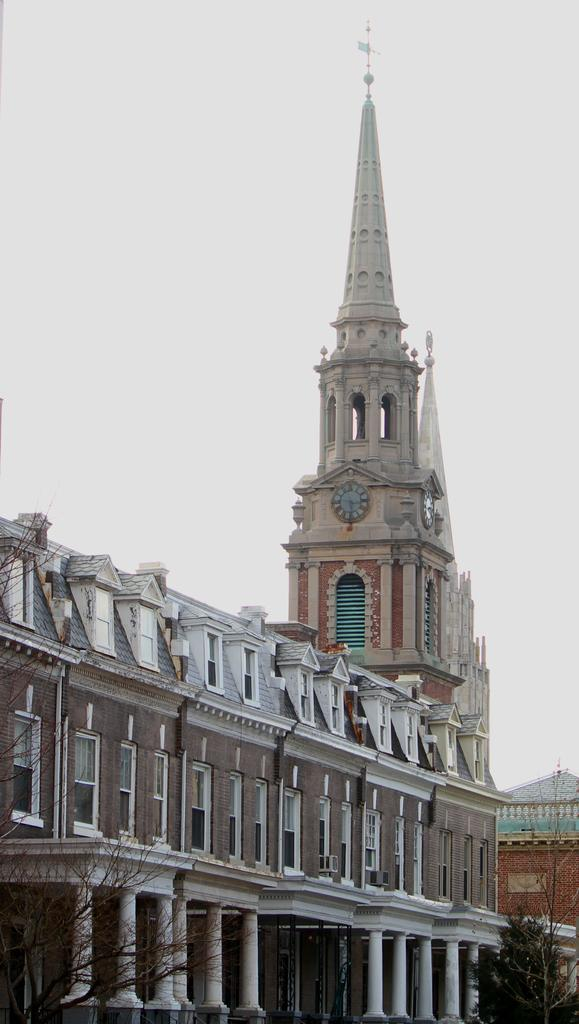What can be seen at the bottom of the picture? There are buildings and trees at the bottom of the picture. What is located behind the buildings and trees? There is a steeple visible behind the buildings and trees. What is visible at the top of the picture? The sky is visible at the top of the picture. Where was the picture taken? The picture was taken outside the city. What direction is the bear facing in the image? There is no bear present in the image. What is the significance of the north in the image? There is no reference to the north or any cardinal directions in the image. 